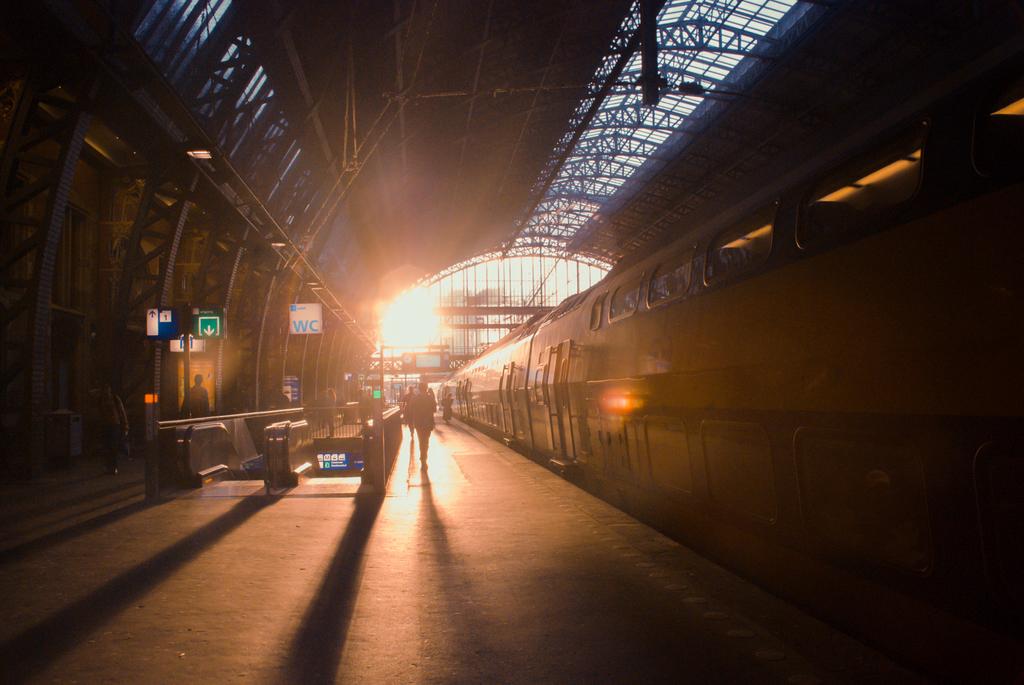What letters are on the sign in blue with white background?
Offer a very short reply. Wc. 